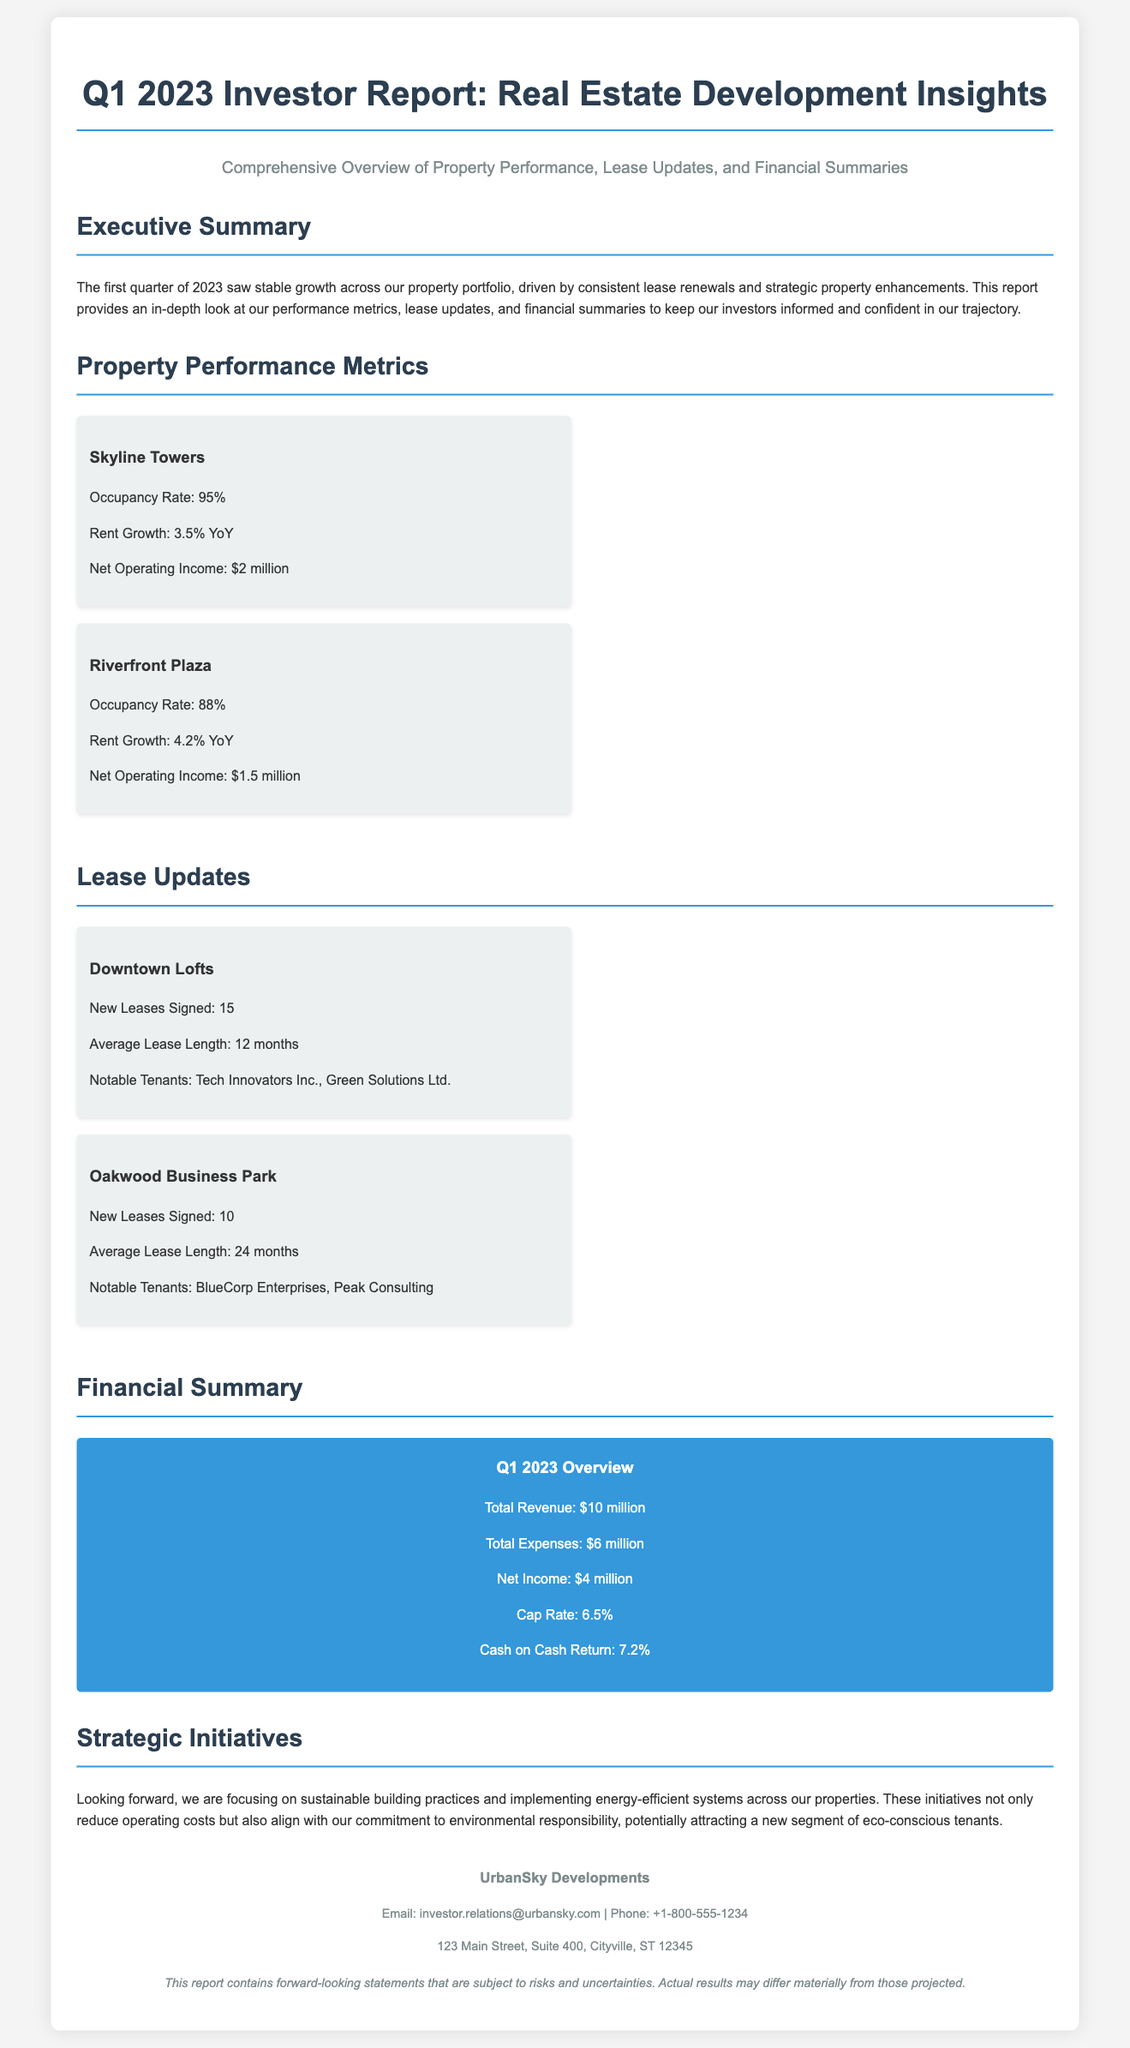What is the occupancy rate of Skyline Towers? The occupancy rate is a performance metric specifically mentioned for Skyline Towers in the document.
Answer: 95% What is the net operating income for Riverfront Plaza? The net operating income is stated directly in the property performance metrics for Riverfront Plaza.
Answer: $1.5 million How many new leases were signed at Downtown Lofts? This information is detailed in the lease updates section for Downtown Lofts.
Answer: 15 What is the average lease length for Oakwood Business Park? The average lease length is specified in the lease updates section about Oakwood Business Park.
Answer: 24 months What was the total revenue for Q1 2023? Total revenue is highlighted in the financial summary section of the report.
Answer: $10 million What is the cap rate reported in the financial summary? The cap rate is one of the financial metrics mentioned in the summary.
Answer: 6.5% What strategic initiatives are being focused on moving forward? This information is presented in the Strategic Initiatives section of the report.
Answer: Sustainable building practices What notable tenants are mentioned for Downtown Lofts? The notable tenants for Downtown Lofts are listed in the lease updates section.
Answer: Tech Innovators Inc., Green Solutions Ltd What is the overall theme of the Executive Summary? The Executive Summary provides an overview of the performance metrics and growth aspects of the properties.
Answer: Stable growth 